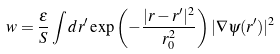Convert formula to latex. <formula><loc_0><loc_0><loc_500><loc_500>w = \frac { \epsilon } { S } \int d r ^ { \prime } \exp \left ( - \frac { | r - r ^ { \prime } | ^ { 2 } } { r _ { 0 } ^ { 2 } } \right ) | \nabla \psi ( r ^ { \prime } ) | ^ { 2 }</formula> 